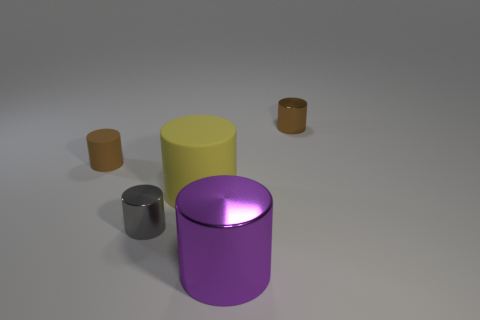Add 2 brown objects. How many objects exist? 7 Subtract all brown shiny cylinders. How many cylinders are left? 4 Subtract all brown cylinders. How many cylinders are left? 3 Subtract 1 cylinders. How many cylinders are left? 4 Add 2 brown rubber cylinders. How many brown rubber cylinders are left? 3 Add 2 metal objects. How many metal objects exist? 5 Subtract 0 red blocks. How many objects are left? 5 Subtract all green cylinders. Subtract all purple balls. How many cylinders are left? 5 Subtract all yellow blocks. How many brown cylinders are left? 2 Subtract all gray shiny cylinders. Subtract all gray metallic objects. How many objects are left? 3 